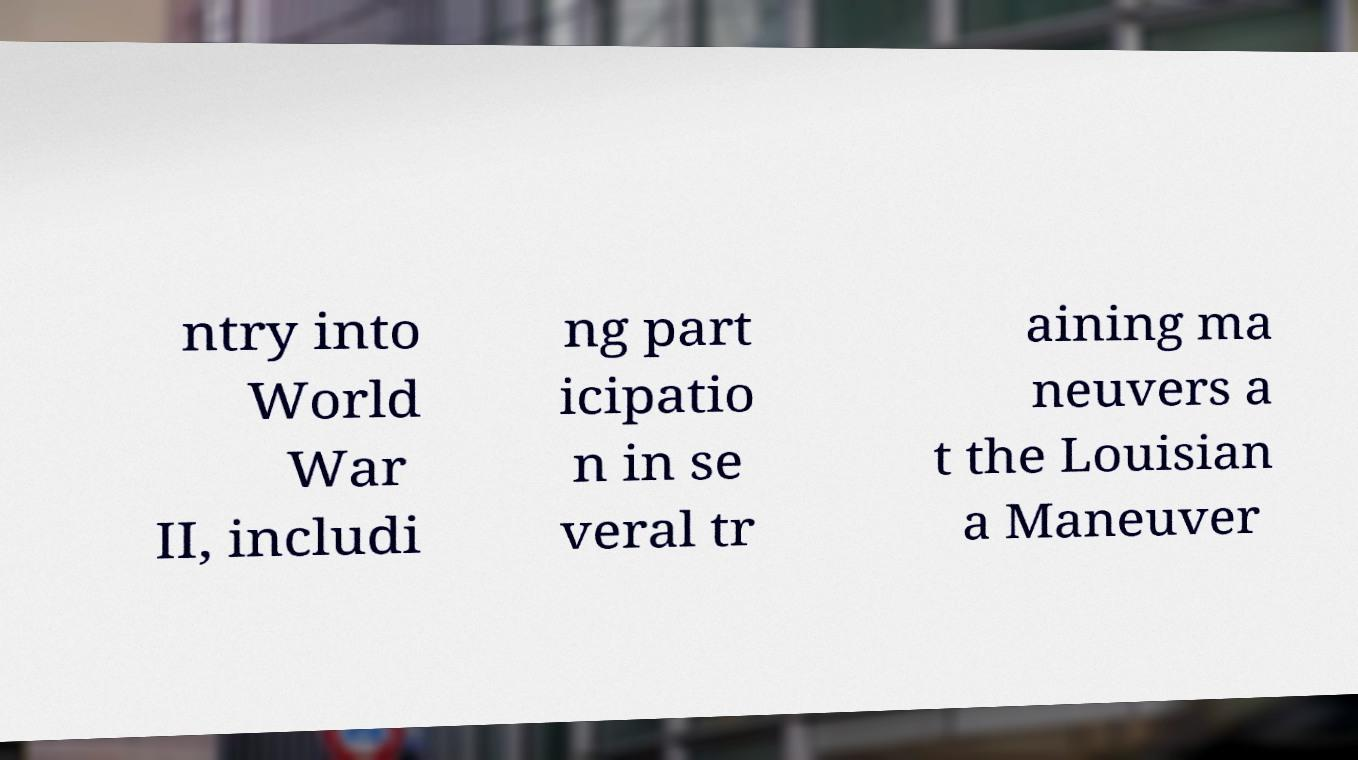Please read and relay the text visible in this image. What does it say? ntry into World War II, includi ng part icipatio n in se veral tr aining ma neuvers a t the Louisian a Maneuver 